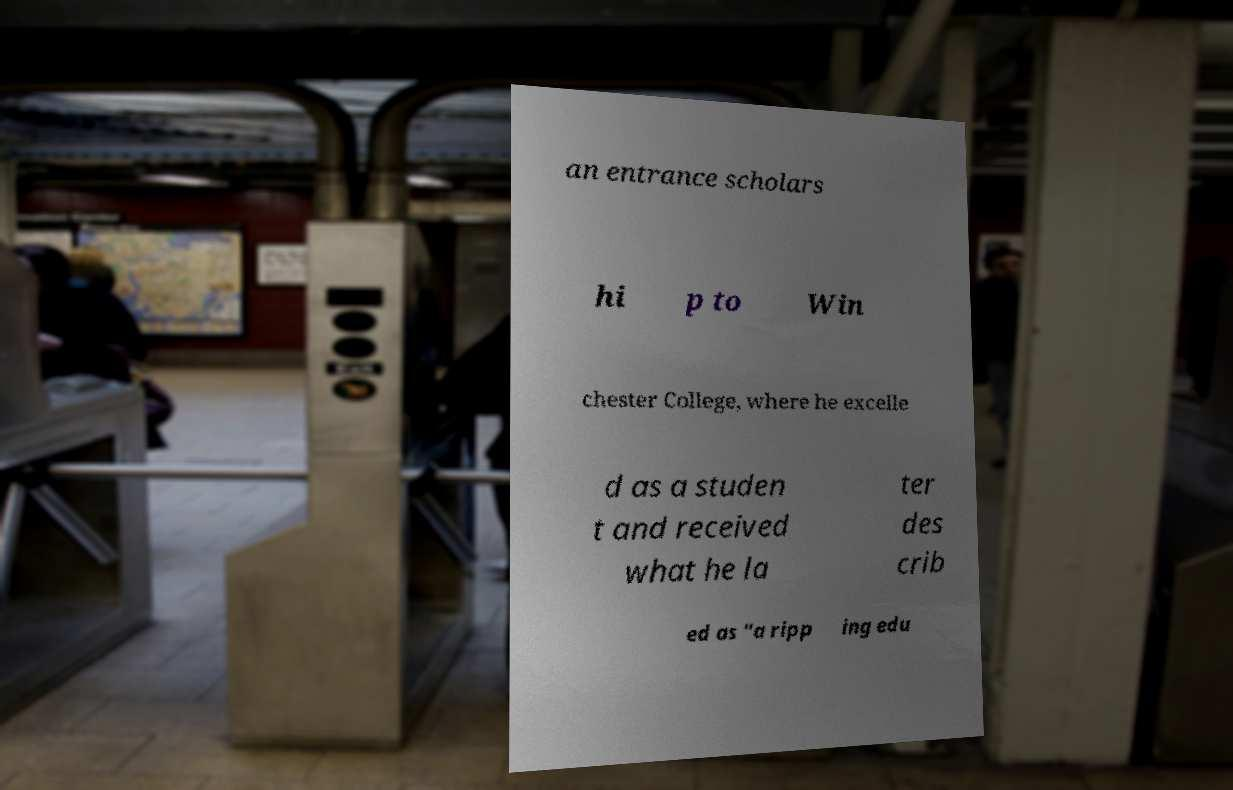Can you read and provide the text displayed in the image?This photo seems to have some interesting text. Can you extract and type it out for me? an entrance scholars hi p to Win chester College, where he excelle d as a studen t and received what he la ter des crib ed as "a ripp ing edu 